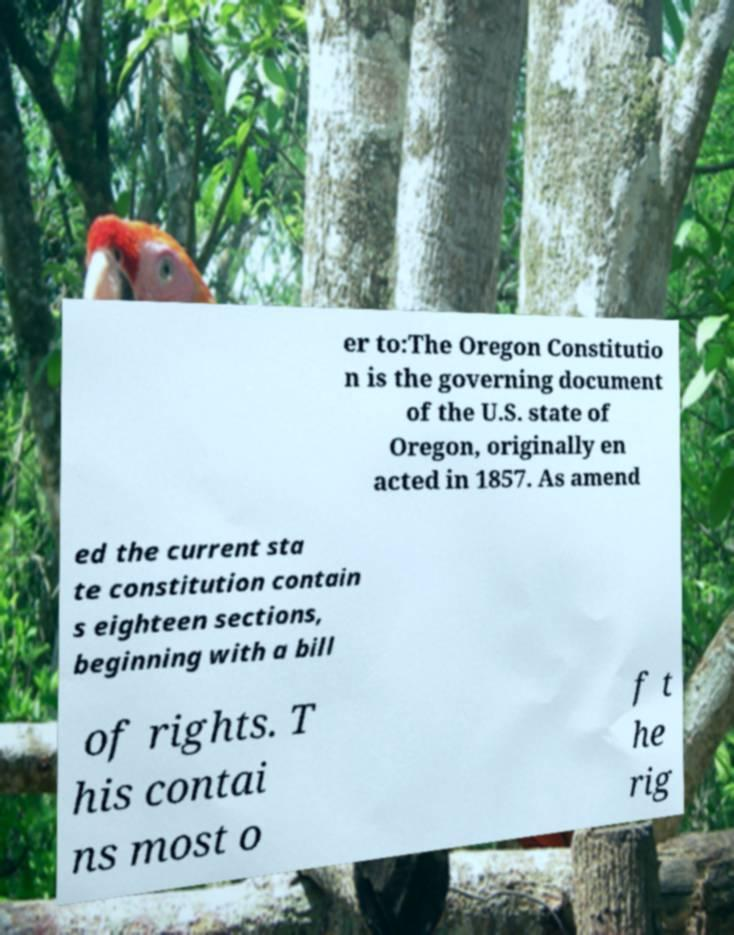Could you extract and type out the text from this image? er to:The Oregon Constitutio n is the governing document of the U.S. state of Oregon, originally en acted in 1857. As amend ed the current sta te constitution contain s eighteen sections, beginning with a bill of rights. T his contai ns most o f t he rig 